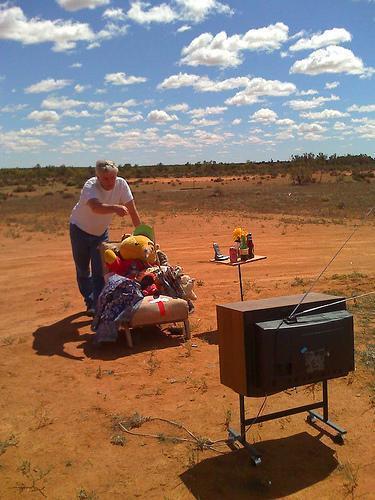How many people are there?
Give a very brief answer. 1. 